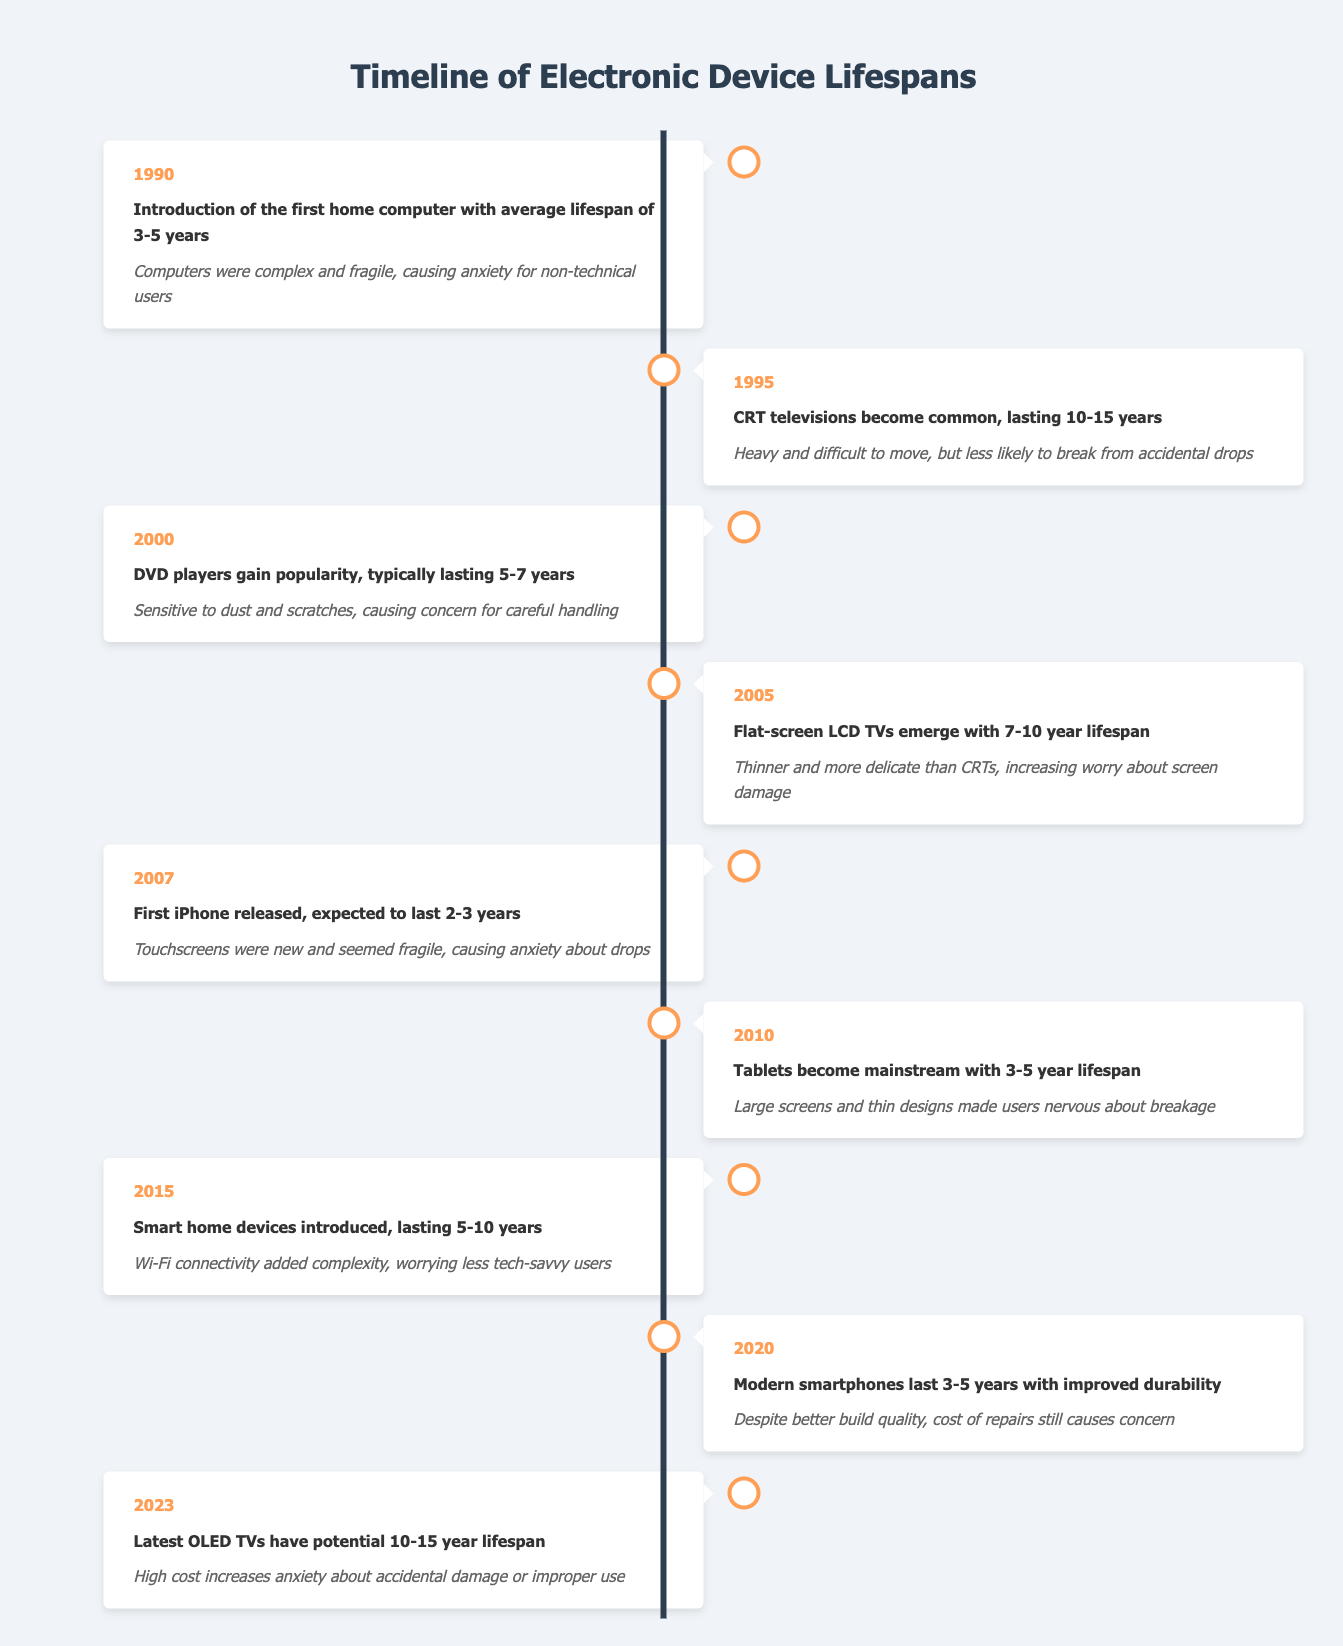What is the lifespan of the first home computer introduced in 1990? The table states that the average lifespan of the first home computer introduced in 1990 is 3-5 years.
Answer: 3-5 years Which electronic device released in 2007 is expected to last 2-3 years? According to the table, the first iPhone was released in 2007 and has an expected lifespan of 2-3 years.
Answer: First iPhone What event in 2015 involved smart home devices? The table indicates that in 2015, smart home devices were introduced, which typically last between 5-10 years.
Answer: Introduction of smart home devices Which device has an average lifespan longer than 10 years? The table highlights that both CRT televisions (introduced in 1995) and OLED TVs (latest in 2023) have lifespans of 10-15 years. Therefore, CRT televisions from 1995 and OLED TVs from 2023 have longer lifespans.
Answer: CRT TVs and OLED TVs What is the average lifespan of flat-screen LCD TVs introduced in 2005? The table shows that flat-screen LCD TVs, first introduced in 2005, have an average lifespan of 7-10 years.
Answer: 7-10 years Are modern smartphones expected to last longer than the first iPhone? The table notes that modern smartphones, introduced around 2020, typically last 3-5 years, while the first iPhone from 2007 is expected to last 2-3 years. Thus, modern smartphones do last longer.
Answer: Yes What is the difference in lifespan between the latest OLED TVs and the first iPhone? The latest OLED TVs are stated to have a potential lifespan of 10-15 years, while the first iPhone has an expected lifespan of 2-3 years. The difference is calculated as follows: for the maximum value, 15 - 3 = 12 years. For the minimum value, 10 - 2 = 8 years. Therefore, the lifespan difference is between 8 to 12 years.
Answer: 8-12 years What types of devices were introduced in the years 2000 and 2010? The table indicates that in 2000, DVD players were introduced, while in 2010, tablets became mainstream.
Answer: DVD players and tablets How many years is the expected lifespan of smart home devices in comparison to DVD players? Smart home devices, introduced in 2015, last 5-10 years, while DVD players, from 2000, typically last 5-7 years. The comparison shows that smart home devices last longer on average.
Answer: Smart home devices last longer 